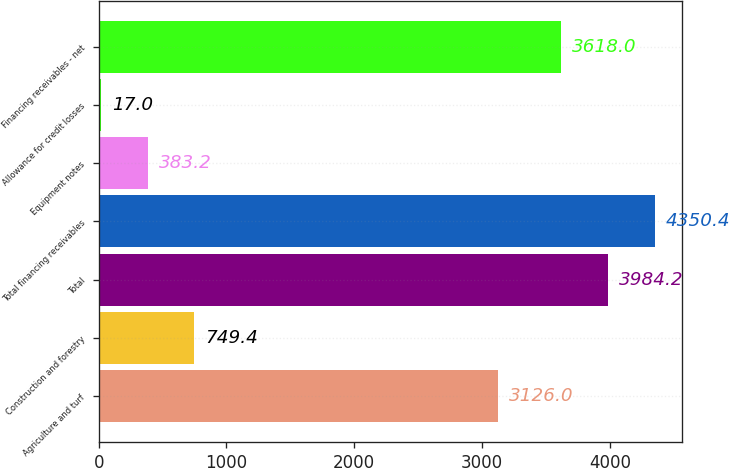Convert chart to OTSL. <chart><loc_0><loc_0><loc_500><loc_500><bar_chart><fcel>Agriculture and turf<fcel>Construction and forestry<fcel>Total<fcel>Total financing receivables<fcel>Equipment notes<fcel>Allowance for credit losses<fcel>Financing receivables - net<nl><fcel>3126<fcel>749.4<fcel>3984.2<fcel>4350.4<fcel>383.2<fcel>17<fcel>3618<nl></chart> 